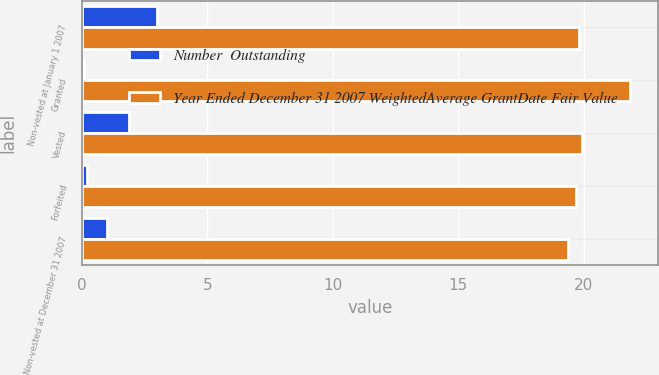<chart> <loc_0><loc_0><loc_500><loc_500><stacked_bar_chart><ecel><fcel>Non-vested at January 1 2007<fcel>Granted<fcel>Vested<fcel>Forfeited<fcel>Non-vested at December 31 2007<nl><fcel>Number  Outstanding<fcel>3<fcel>0.1<fcel>1.9<fcel>0.2<fcel>1<nl><fcel>Year Ended December 31 2007 WeightedAverage GrantDate Fair Value<fcel>19.8<fcel>21.86<fcel>19.94<fcel>19.7<fcel>19.39<nl></chart> 